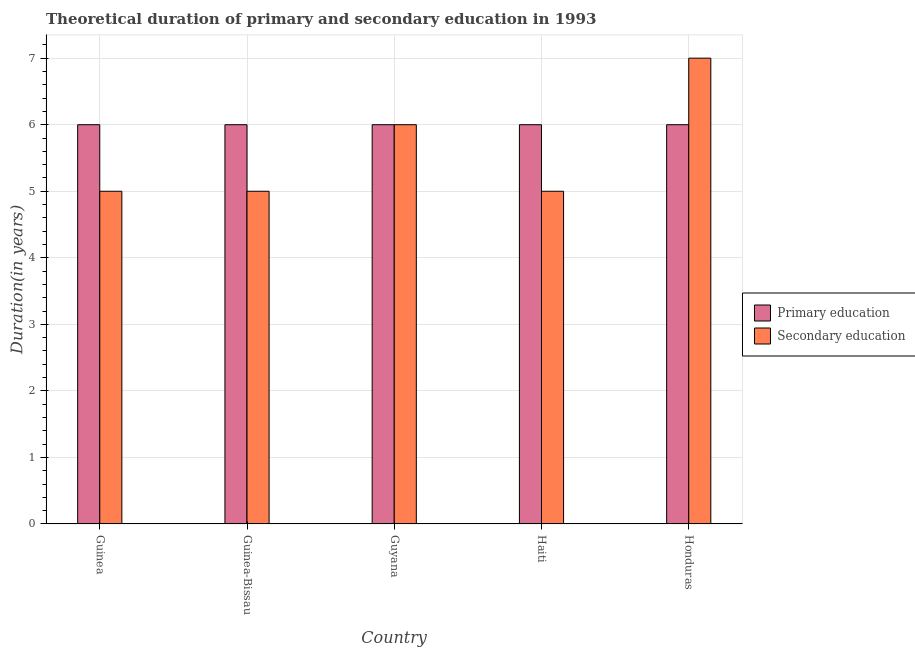How many groups of bars are there?
Offer a very short reply. 5. Are the number of bars per tick equal to the number of legend labels?
Offer a terse response. Yes. Are the number of bars on each tick of the X-axis equal?
Give a very brief answer. Yes. How many bars are there on the 1st tick from the right?
Ensure brevity in your answer.  2. What is the label of the 5th group of bars from the left?
Offer a terse response. Honduras. In how many cases, is the number of bars for a given country not equal to the number of legend labels?
Make the answer very short. 0. Across all countries, what is the maximum duration of secondary education?
Your response must be concise. 7. Across all countries, what is the minimum duration of primary education?
Offer a terse response. 6. In which country was the duration of primary education maximum?
Offer a very short reply. Guinea. In which country was the duration of primary education minimum?
Keep it short and to the point. Guinea. What is the total duration of secondary education in the graph?
Your answer should be compact. 28. What is the difference between the duration of primary education in Guyana and the duration of secondary education in Haiti?
Ensure brevity in your answer.  1. What is the difference between the duration of primary education and duration of secondary education in Guinea-Bissau?
Offer a terse response. 1. What is the ratio of the duration of primary education in Guinea to that in Honduras?
Give a very brief answer. 1. What is the difference between the highest and the lowest duration of secondary education?
Give a very brief answer. 2. In how many countries, is the duration of secondary education greater than the average duration of secondary education taken over all countries?
Your answer should be compact. 2. Is the sum of the duration of secondary education in Guinea and Honduras greater than the maximum duration of primary education across all countries?
Your answer should be very brief. Yes. What does the 1st bar from the right in Guyana represents?
Keep it short and to the point. Secondary education. How many bars are there?
Make the answer very short. 10. What is the difference between two consecutive major ticks on the Y-axis?
Offer a very short reply. 1. Does the graph contain any zero values?
Your answer should be very brief. No. What is the title of the graph?
Make the answer very short. Theoretical duration of primary and secondary education in 1993. Does "% of GNI" appear as one of the legend labels in the graph?
Ensure brevity in your answer.  No. What is the label or title of the X-axis?
Make the answer very short. Country. What is the label or title of the Y-axis?
Ensure brevity in your answer.  Duration(in years). What is the Duration(in years) in Secondary education in Guinea?
Your answer should be compact. 5. What is the Duration(in years) of Secondary education in Guyana?
Your response must be concise. 6. What is the Duration(in years) of Primary education in Honduras?
Give a very brief answer. 6. What is the Duration(in years) of Secondary education in Honduras?
Provide a short and direct response. 7. Across all countries, what is the maximum Duration(in years) of Secondary education?
Offer a very short reply. 7. Across all countries, what is the minimum Duration(in years) of Primary education?
Keep it short and to the point. 6. What is the total Duration(in years) of Primary education in the graph?
Give a very brief answer. 30. What is the difference between the Duration(in years) of Primary education in Guinea and that in Guinea-Bissau?
Provide a succinct answer. 0. What is the difference between the Duration(in years) of Secondary education in Guinea and that in Guinea-Bissau?
Ensure brevity in your answer.  0. What is the difference between the Duration(in years) of Primary education in Guinea and that in Guyana?
Give a very brief answer. 0. What is the difference between the Duration(in years) of Secondary education in Guinea and that in Guyana?
Keep it short and to the point. -1. What is the difference between the Duration(in years) of Primary education in Guinea and that in Haiti?
Ensure brevity in your answer.  0. What is the difference between the Duration(in years) in Primary education in Guinea-Bissau and that in Guyana?
Make the answer very short. 0. What is the difference between the Duration(in years) in Primary education in Guinea-Bissau and that in Haiti?
Offer a terse response. 0. What is the difference between the Duration(in years) of Primary education in Guinea-Bissau and that in Honduras?
Give a very brief answer. 0. What is the difference between the Duration(in years) of Secondary education in Guinea-Bissau and that in Honduras?
Your response must be concise. -2. What is the difference between the Duration(in years) of Secondary education in Guyana and that in Haiti?
Offer a terse response. 1. What is the difference between the Duration(in years) in Secondary education in Guyana and that in Honduras?
Provide a short and direct response. -1. What is the difference between the Duration(in years) of Primary education in Haiti and that in Honduras?
Your answer should be compact. 0. What is the difference between the Duration(in years) in Secondary education in Haiti and that in Honduras?
Your answer should be very brief. -2. What is the difference between the Duration(in years) of Primary education in Guinea and the Duration(in years) of Secondary education in Guyana?
Offer a terse response. 0. What is the difference between the Duration(in years) in Primary education in Guinea and the Duration(in years) in Secondary education in Honduras?
Give a very brief answer. -1. What is the difference between the Duration(in years) in Primary education in Guinea-Bissau and the Duration(in years) in Secondary education in Honduras?
Your response must be concise. -1. What is the difference between the Duration(in years) of Primary education in Guyana and the Duration(in years) of Secondary education in Honduras?
Give a very brief answer. -1. What is the difference between the Duration(in years) of Primary education in Haiti and the Duration(in years) of Secondary education in Honduras?
Your answer should be compact. -1. What is the average Duration(in years) in Secondary education per country?
Provide a short and direct response. 5.6. What is the difference between the Duration(in years) in Primary education and Duration(in years) in Secondary education in Guinea?
Give a very brief answer. 1. What is the difference between the Duration(in years) in Primary education and Duration(in years) in Secondary education in Guinea-Bissau?
Give a very brief answer. 1. What is the difference between the Duration(in years) of Primary education and Duration(in years) of Secondary education in Haiti?
Keep it short and to the point. 1. What is the ratio of the Duration(in years) in Secondary education in Guinea to that in Guyana?
Make the answer very short. 0.83. What is the ratio of the Duration(in years) of Primary education in Guinea to that in Haiti?
Provide a succinct answer. 1. What is the ratio of the Duration(in years) of Secondary education in Guinea to that in Haiti?
Your answer should be very brief. 1. What is the ratio of the Duration(in years) in Secondary education in Guinea-Bissau to that in Haiti?
Offer a terse response. 1. What is the ratio of the Duration(in years) in Primary education in Guinea-Bissau to that in Honduras?
Your answer should be very brief. 1. What is the ratio of the Duration(in years) of Secondary education in Guyana to that in Haiti?
Offer a terse response. 1.2. What is the ratio of the Duration(in years) of Primary education in Haiti to that in Honduras?
Keep it short and to the point. 1. What is the ratio of the Duration(in years) in Secondary education in Haiti to that in Honduras?
Your response must be concise. 0.71. What is the difference between the highest and the second highest Duration(in years) of Primary education?
Give a very brief answer. 0. What is the difference between the highest and the second highest Duration(in years) in Secondary education?
Keep it short and to the point. 1. 